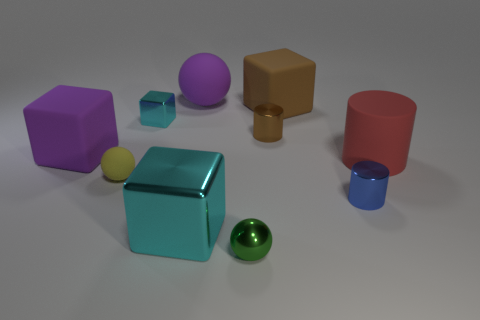If I wanted to stack these objects to create the tallest tower possible, which should I put at the bottom? For the tallest and most stable tower, you should start with the blue cube at the bottom given its size and stability. Then you can progressively add smaller objects on top, finishing with the smallest objects like the little yellow ball or the miniature blue cylinder. 